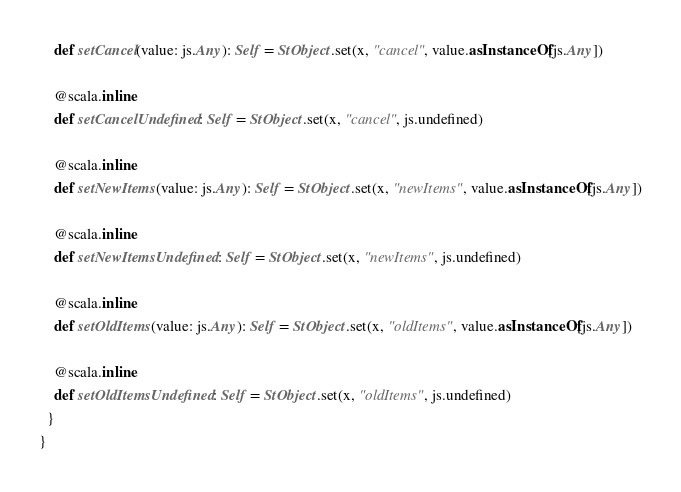Convert code to text. <code><loc_0><loc_0><loc_500><loc_500><_Scala_>    def setCancel(value: js.Any): Self = StObject.set(x, "cancel", value.asInstanceOf[js.Any])
    
    @scala.inline
    def setCancelUndefined: Self = StObject.set(x, "cancel", js.undefined)
    
    @scala.inline
    def setNewItems(value: js.Any): Self = StObject.set(x, "newItems", value.asInstanceOf[js.Any])
    
    @scala.inline
    def setNewItemsUndefined: Self = StObject.set(x, "newItems", js.undefined)
    
    @scala.inline
    def setOldItems(value: js.Any): Self = StObject.set(x, "oldItems", value.asInstanceOf[js.Any])
    
    @scala.inline
    def setOldItemsUndefined: Self = StObject.set(x, "oldItems", js.undefined)
  }
}
</code> 